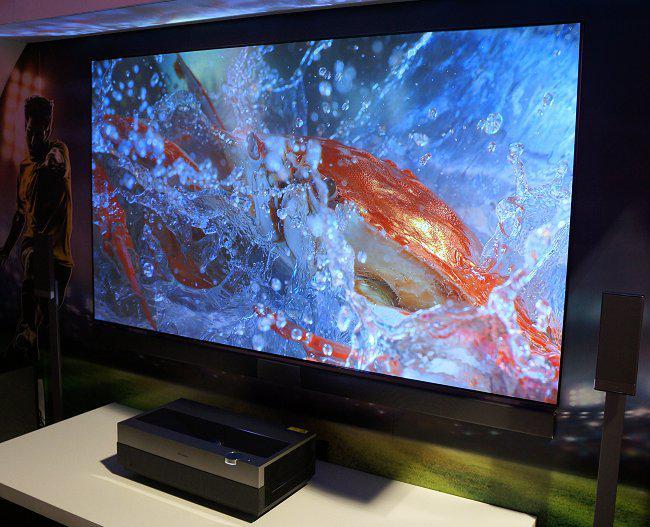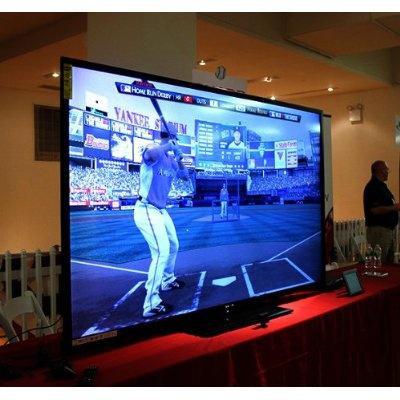The first image is the image on the left, the second image is the image on the right. Analyze the images presented: Is the assertion "The image in the right television display portrays a person." valid? Answer yes or no. Yes. The first image is the image on the left, the second image is the image on the right. Examine the images to the left and right. Is the description "One image shows an arch over a screen displaying a picture of red and blue berries around a shiny red rounded thing." accurate? Answer yes or no. No. 